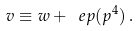<formula> <loc_0><loc_0><loc_500><loc_500>v \equiv w + \ e p ( p ^ { 4 } ) \, .</formula> 